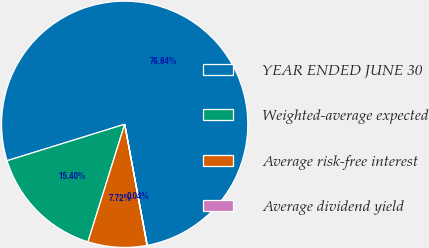Convert chart. <chart><loc_0><loc_0><loc_500><loc_500><pie_chart><fcel>YEAR ENDED JUNE 30<fcel>Weighted-average expected<fcel>Average risk-free interest<fcel>Average dividend yield<nl><fcel>76.84%<fcel>15.4%<fcel>7.72%<fcel>0.04%<nl></chart> 